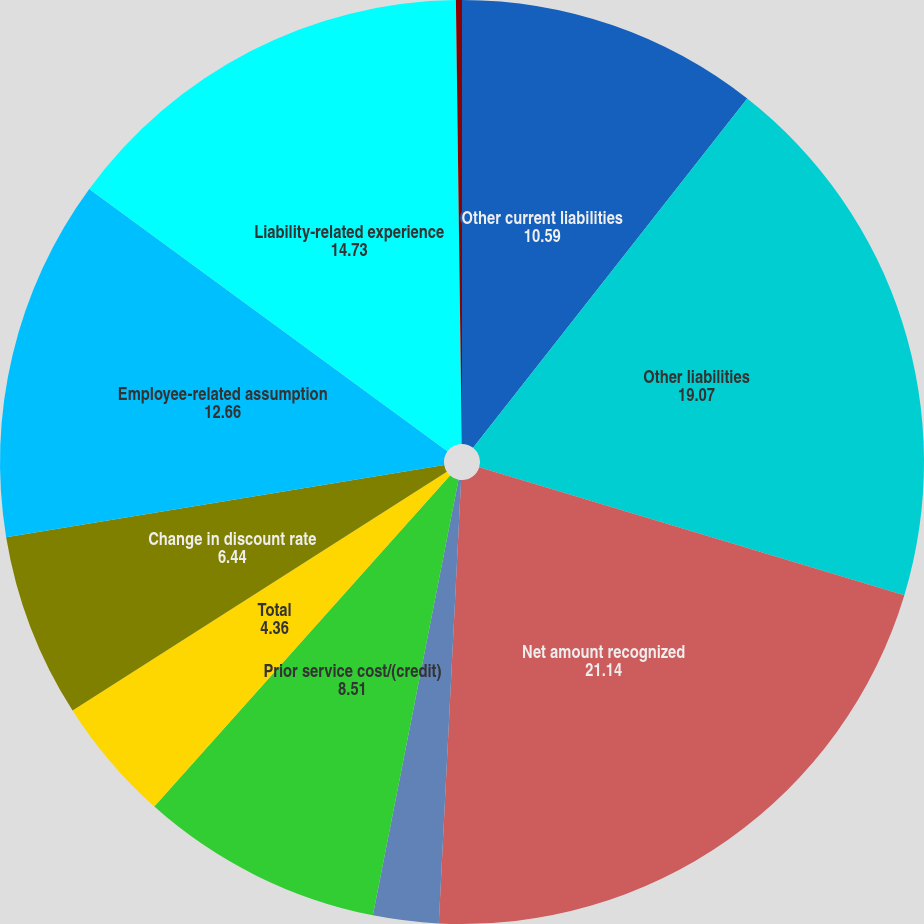Convert chart to OTSL. <chart><loc_0><loc_0><loc_500><loc_500><pie_chart><fcel>Other current liabilities<fcel>Other liabilities<fcel>Net amount recognized<fcel>Net loss/(gain)<fcel>Prior service cost/(credit)<fcel>Total<fcel>Change in discount rate<fcel>Employee-related assumption<fcel>Liability-related experience<fcel>Actual asset return different<nl><fcel>10.59%<fcel>19.07%<fcel>21.14%<fcel>2.29%<fcel>8.51%<fcel>4.36%<fcel>6.44%<fcel>12.66%<fcel>14.73%<fcel>0.21%<nl></chart> 